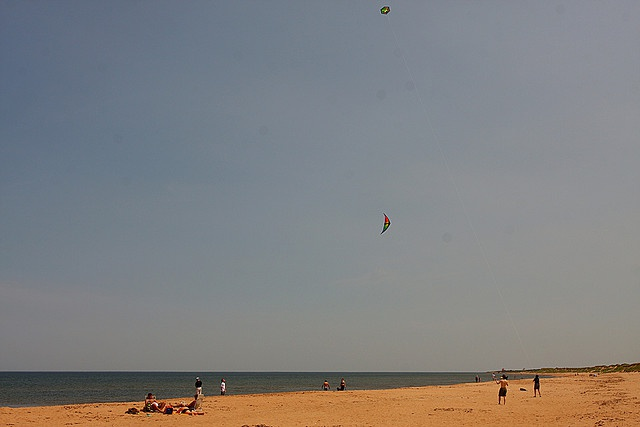Describe the objects in this image and their specific colors. I can see people in gray, black, maroon, and red tones, people in gray, black, maroon, tan, and brown tones, people in gray, black, tan, maroon, and brown tones, kite in gray, darkgray, black, and maroon tones, and people in gray, black, maroon, and lavender tones in this image. 